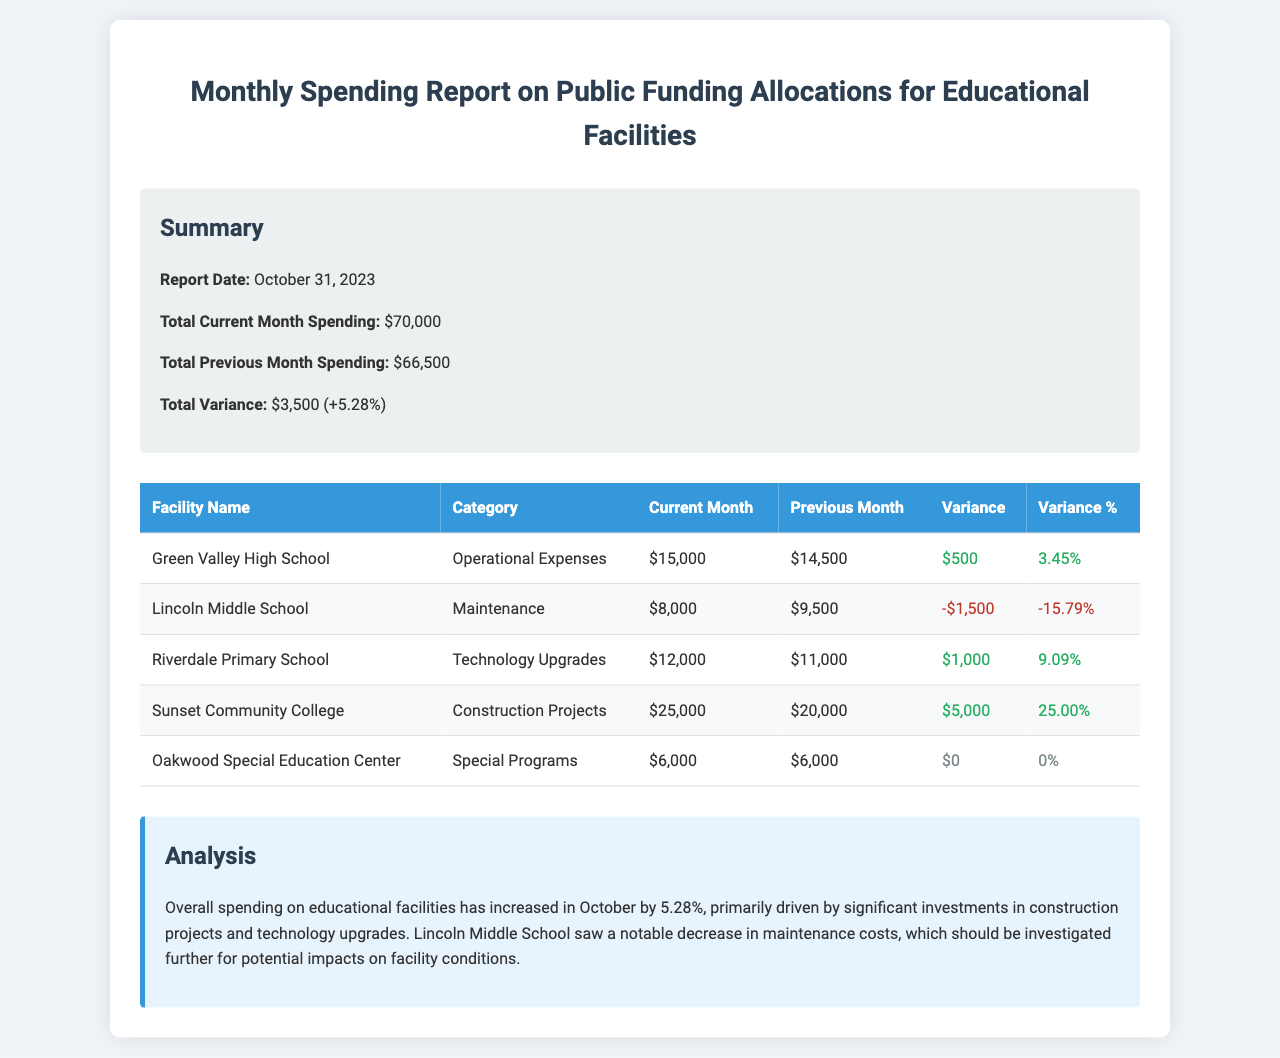what is the report date? The report date is explicitly stated in the summary section of the document.
Answer: October 31, 2023 what is the total current month spending? The total current month spending is clearly mentioned in the summary section of the document.
Answer: $70,000 which facility had the highest spending in the current month? By comparing the current month spending, Sunset Community College shows the highest allocation among all facilities.
Answer: Sunset Community College what category did Lincoln Middle School spend on? The category for Lincoln Middle School is provided in the table summarizing spending by facility.
Answer: Maintenance what was the variance for Riverdale Primary School? The variance for Riverdale Primary School is noted as a specific dollar amount in the spending report table.
Answer: $1,000 overall, how much did spending increase compared to the previous month? The increase in spending is summed up in the summary section of the document as the total variance percentage.
Answer: 5.28% which category had a decrease in spending? The table lists all categories and highlights a decrease for one specific facility, indicating the category with a decline.
Answer: Maintenance how much did Oakwood Special Education Center spend in the current month? The current month spending for Oakwood Special Education Center is listed in the report table.
Answer: $6,000 what spending category saw the largest percentage increase? By reviewing the variance percentages in the table, you can identify the category with the most significant increase.
Answer: Construction Projects 